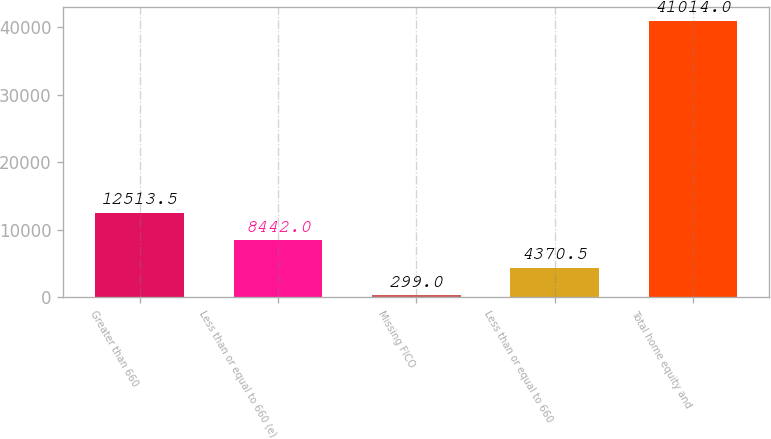Convert chart. <chart><loc_0><loc_0><loc_500><loc_500><bar_chart><fcel>Greater than 660<fcel>Less than or equal to 660 (e)<fcel>Missing FICO<fcel>Less than or equal to 660<fcel>Total home equity and<nl><fcel>12513.5<fcel>8442<fcel>299<fcel>4370.5<fcel>41014<nl></chart> 